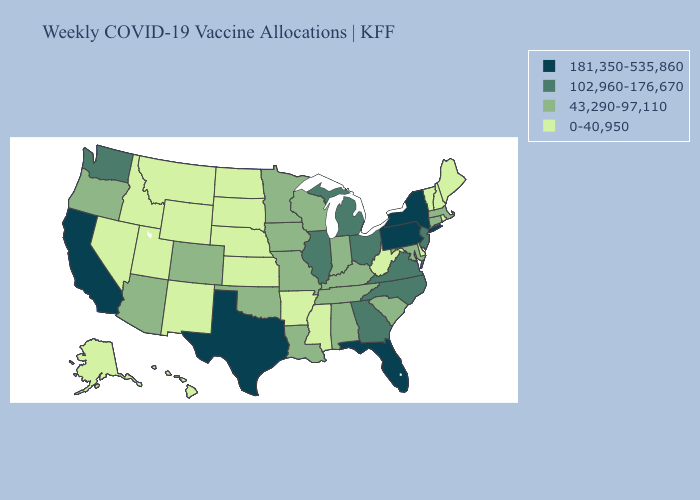Which states have the highest value in the USA?
Answer briefly. California, Florida, New York, Pennsylvania, Texas. What is the highest value in states that border Colorado?
Short answer required. 43,290-97,110. Does Georgia have the lowest value in the South?
Write a very short answer. No. What is the lowest value in the USA?
Keep it brief. 0-40,950. Does the first symbol in the legend represent the smallest category?
Write a very short answer. No. What is the value of Maryland?
Keep it brief. 43,290-97,110. What is the lowest value in the MidWest?
Short answer required. 0-40,950. Among the states that border Virginia , which have the lowest value?
Short answer required. West Virginia. Name the states that have a value in the range 102,960-176,670?
Keep it brief. Georgia, Illinois, Michigan, New Jersey, North Carolina, Ohio, Virginia, Washington. What is the highest value in the USA?
Give a very brief answer. 181,350-535,860. Does New Mexico have a lower value than Utah?
Be succinct. No. What is the value of Tennessee?
Be succinct. 43,290-97,110. Is the legend a continuous bar?
Short answer required. No. Does Vermont have a lower value than Ohio?
Quick response, please. Yes. What is the lowest value in states that border Maryland?
Short answer required. 0-40,950. 